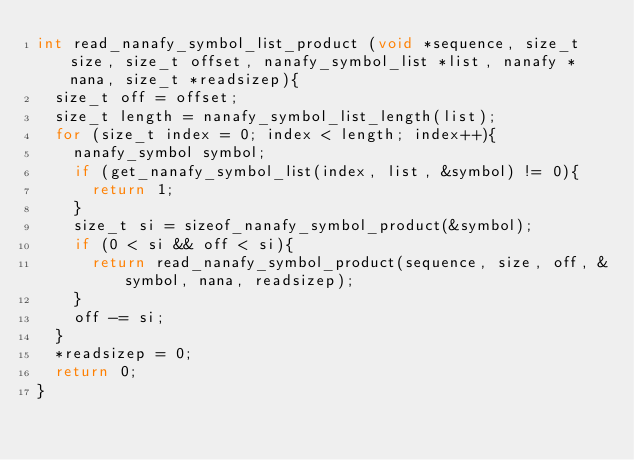Convert code to text. <code><loc_0><loc_0><loc_500><loc_500><_C_>int read_nanafy_symbol_list_product (void *sequence, size_t size, size_t offset, nanafy_symbol_list *list, nanafy *nana, size_t *readsizep){
	size_t off = offset;
	size_t length = nanafy_symbol_list_length(list);
	for (size_t index = 0; index < length; index++){
		nanafy_symbol symbol;
		if (get_nanafy_symbol_list(index, list, &symbol) != 0){
			return 1;
		}
		size_t si = sizeof_nanafy_symbol_product(&symbol);
		if (0 < si && off < si){
			return read_nanafy_symbol_product(sequence, size, off, &symbol, nana, readsizep);
		}
		off -= si;
	}
	*readsizep = 0;
	return 0;
}
</code> 